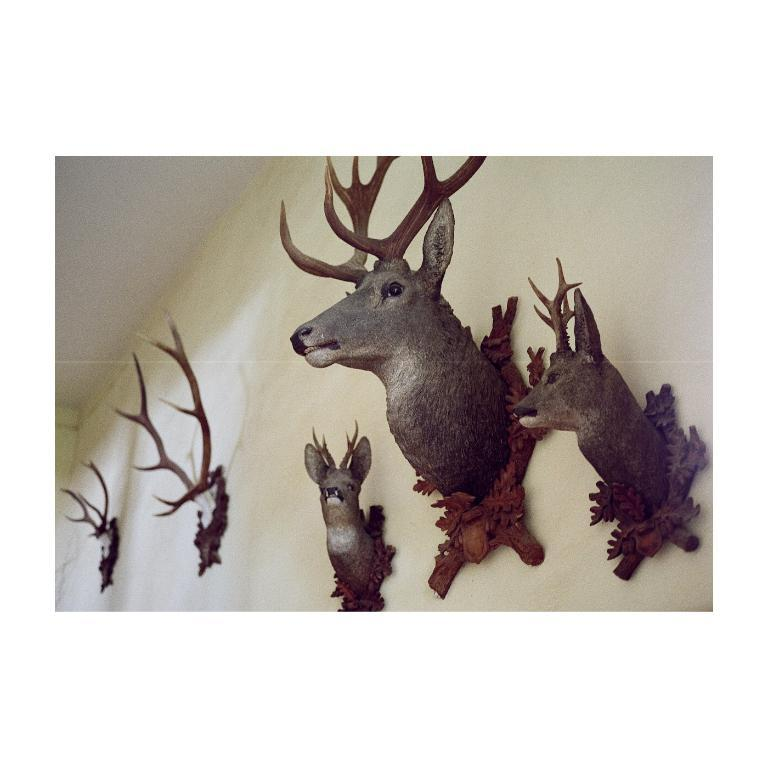What type of decorations can be seen on the wall in the image? There are elk head decors on the wall in the image. How many jellyfish are swimming in the account shown in the image? There are no jellyfish or accounts present in the image; it features elk head decorations on the wall. 